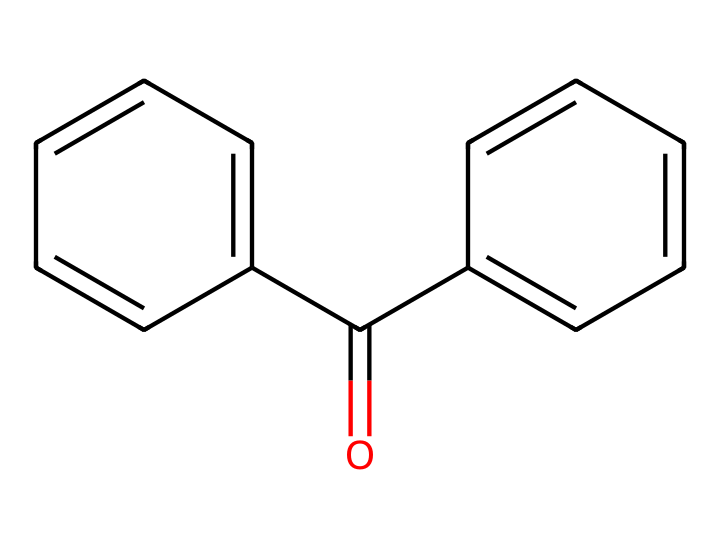What is the common name of this chemical? The chemical structure shows a carbonyl group attached to two phenyl rings, which is characteristic of benzophenone.
Answer: benzophenone How many carbon atoms are in this molecule? Analyzing the SMILES, there are ten carbon atoms indicated by the 'c' (for aromatic carbons) and 'C' (for aliphatic carbon) present in the structure.
Answer: 13 What functional group is present in benzophenone? The structure has a carbonyl group (C=O) indicated by the double bond to oxygen, which is typical for ketones.
Answer: carbonyl How many aromatic rings does benzophenone contain? The structure shows two phenyl (benzene) rings connected to the central carbonyl group. Each of the cyclic parts of the structure is an aromatic ring.
Answer: 2 What type of chemical compound is benzophenone classified as? The presence of the ketone functional group and the structure designating it with both carbonyl and aromatic rings classifies it as a ketone.
Answer: ketone What role does benzophenone play in UV protection? Benzophenone absorbs UV light, preventing damage to materials and is often used in coatings to protect electronic devices from UV radiation.
Answer: UV absorber 